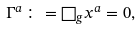Convert formula to latex. <formula><loc_0><loc_0><loc_500><loc_500>\Gamma ^ { a } \colon = \Box _ { g } x ^ { a } = 0 ,</formula> 